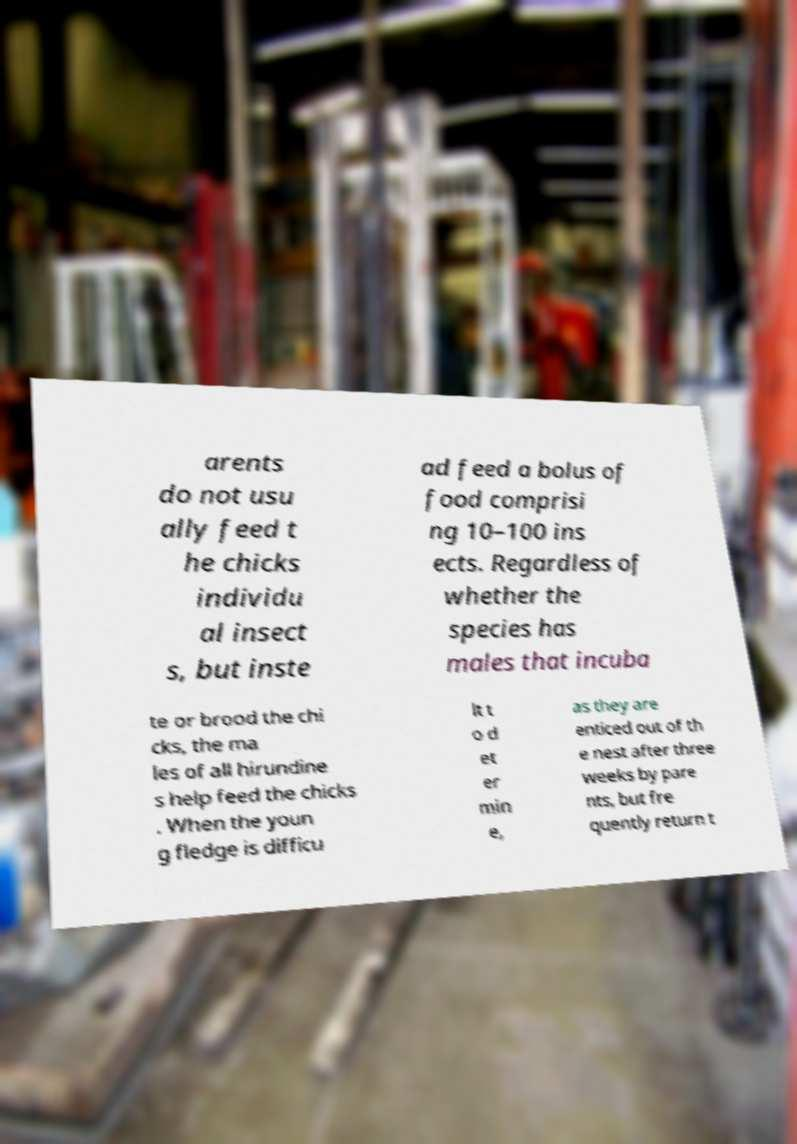I need the written content from this picture converted into text. Can you do that? arents do not usu ally feed t he chicks individu al insect s, but inste ad feed a bolus of food comprisi ng 10–100 ins ects. Regardless of whether the species has males that incuba te or brood the chi cks, the ma les of all hirundine s help feed the chicks . When the youn g fledge is difficu lt t o d et er min e, as they are enticed out of th e nest after three weeks by pare nts, but fre quently return t 